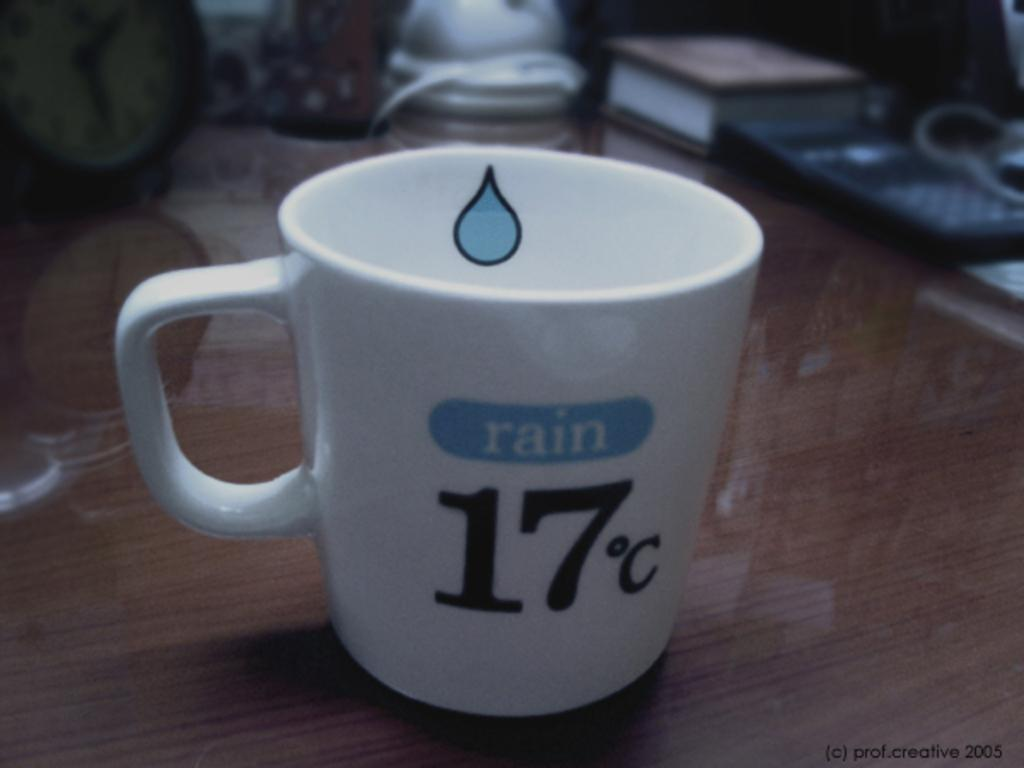<image>
Render a clear and concise summary of the photo. a cup that says rain on the top 